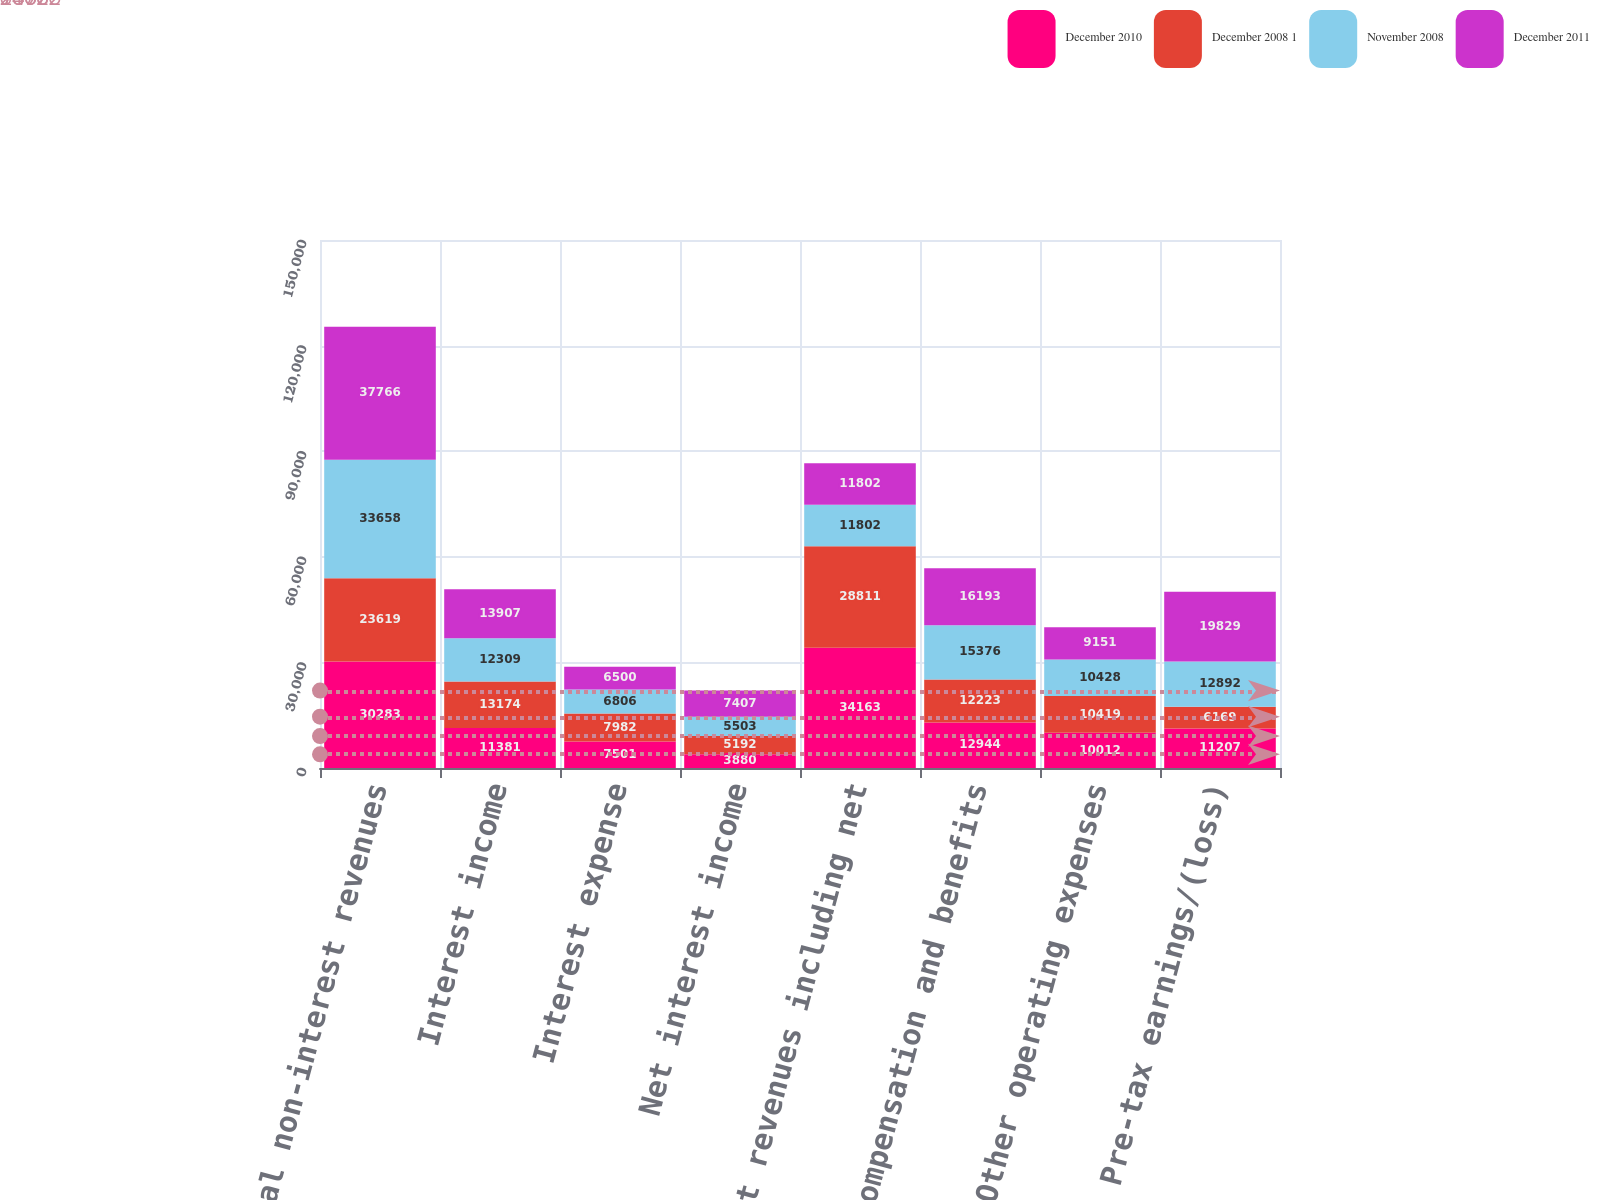Convert chart. <chart><loc_0><loc_0><loc_500><loc_500><stacked_bar_chart><ecel><fcel>Total non-interest revenues<fcel>Interest income<fcel>Interest expense<fcel>Net interest income<fcel>Net revenues including net<fcel>Compensation and benefits<fcel>Other operating expenses<fcel>Pre-tax earnings/(loss)<nl><fcel>December 2010<fcel>30283<fcel>11381<fcel>7501<fcel>3880<fcel>34163<fcel>12944<fcel>10012<fcel>11207<nl><fcel>December 2008 1<fcel>23619<fcel>13174<fcel>7982<fcel>5192<fcel>28811<fcel>12223<fcel>10419<fcel>6169<nl><fcel>November 2008<fcel>33658<fcel>12309<fcel>6806<fcel>5503<fcel>11802<fcel>15376<fcel>10428<fcel>12892<nl><fcel>December 2011<fcel>37766<fcel>13907<fcel>6500<fcel>7407<fcel>11802<fcel>16193<fcel>9151<fcel>19829<nl></chart> 